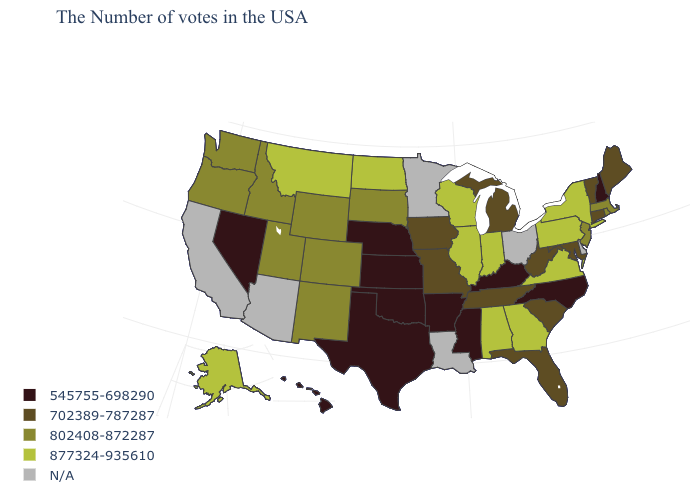Among the states that border Colorado , which have the highest value?
Short answer required. Wyoming, New Mexico, Utah. Which states have the lowest value in the West?
Give a very brief answer. Nevada, Hawaii. Name the states that have a value in the range N/A?
Answer briefly. Delaware, Ohio, Louisiana, Minnesota, Arizona, California. Does the first symbol in the legend represent the smallest category?
Keep it brief. Yes. Which states hav the highest value in the West?
Quick response, please. Montana, Alaska. Name the states that have a value in the range 802408-872287?
Write a very short answer. Massachusetts, Rhode Island, New Jersey, South Dakota, Wyoming, Colorado, New Mexico, Utah, Idaho, Washington, Oregon. What is the highest value in the West ?
Be succinct. 877324-935610. What is the highest value in states that border Montana?
Keep it brief. 877324-935610. Name the states that have a value in the range 877324-935610?
Short answer required. New York, Pennsylvania, Virginia, Georgia, Indiana, Alabama, Wisconsin, Illinois, North Dakota, Montana, Alaska. What is the value of Delaware?
Write a very short answer. N/A. Does New Hampshire have the lowest value in the Northeast?
Give a very brief answer. Yes. What is the value of Delaware?
Concise answer only. N/A. Does North Carolina have the lowest value in the USA?
Keep it brief. Yes. Name the states that have a value in the range 702389-787287?
Quick response, please. Maine, Vermont, Connecticut, Maryland, South Carolina, West Virginia, Florida, Michigan, Tennessee, Missouri, Iowa. Does Oklahoma have the lowest value in the USA?
Answer briefly. Yes. 